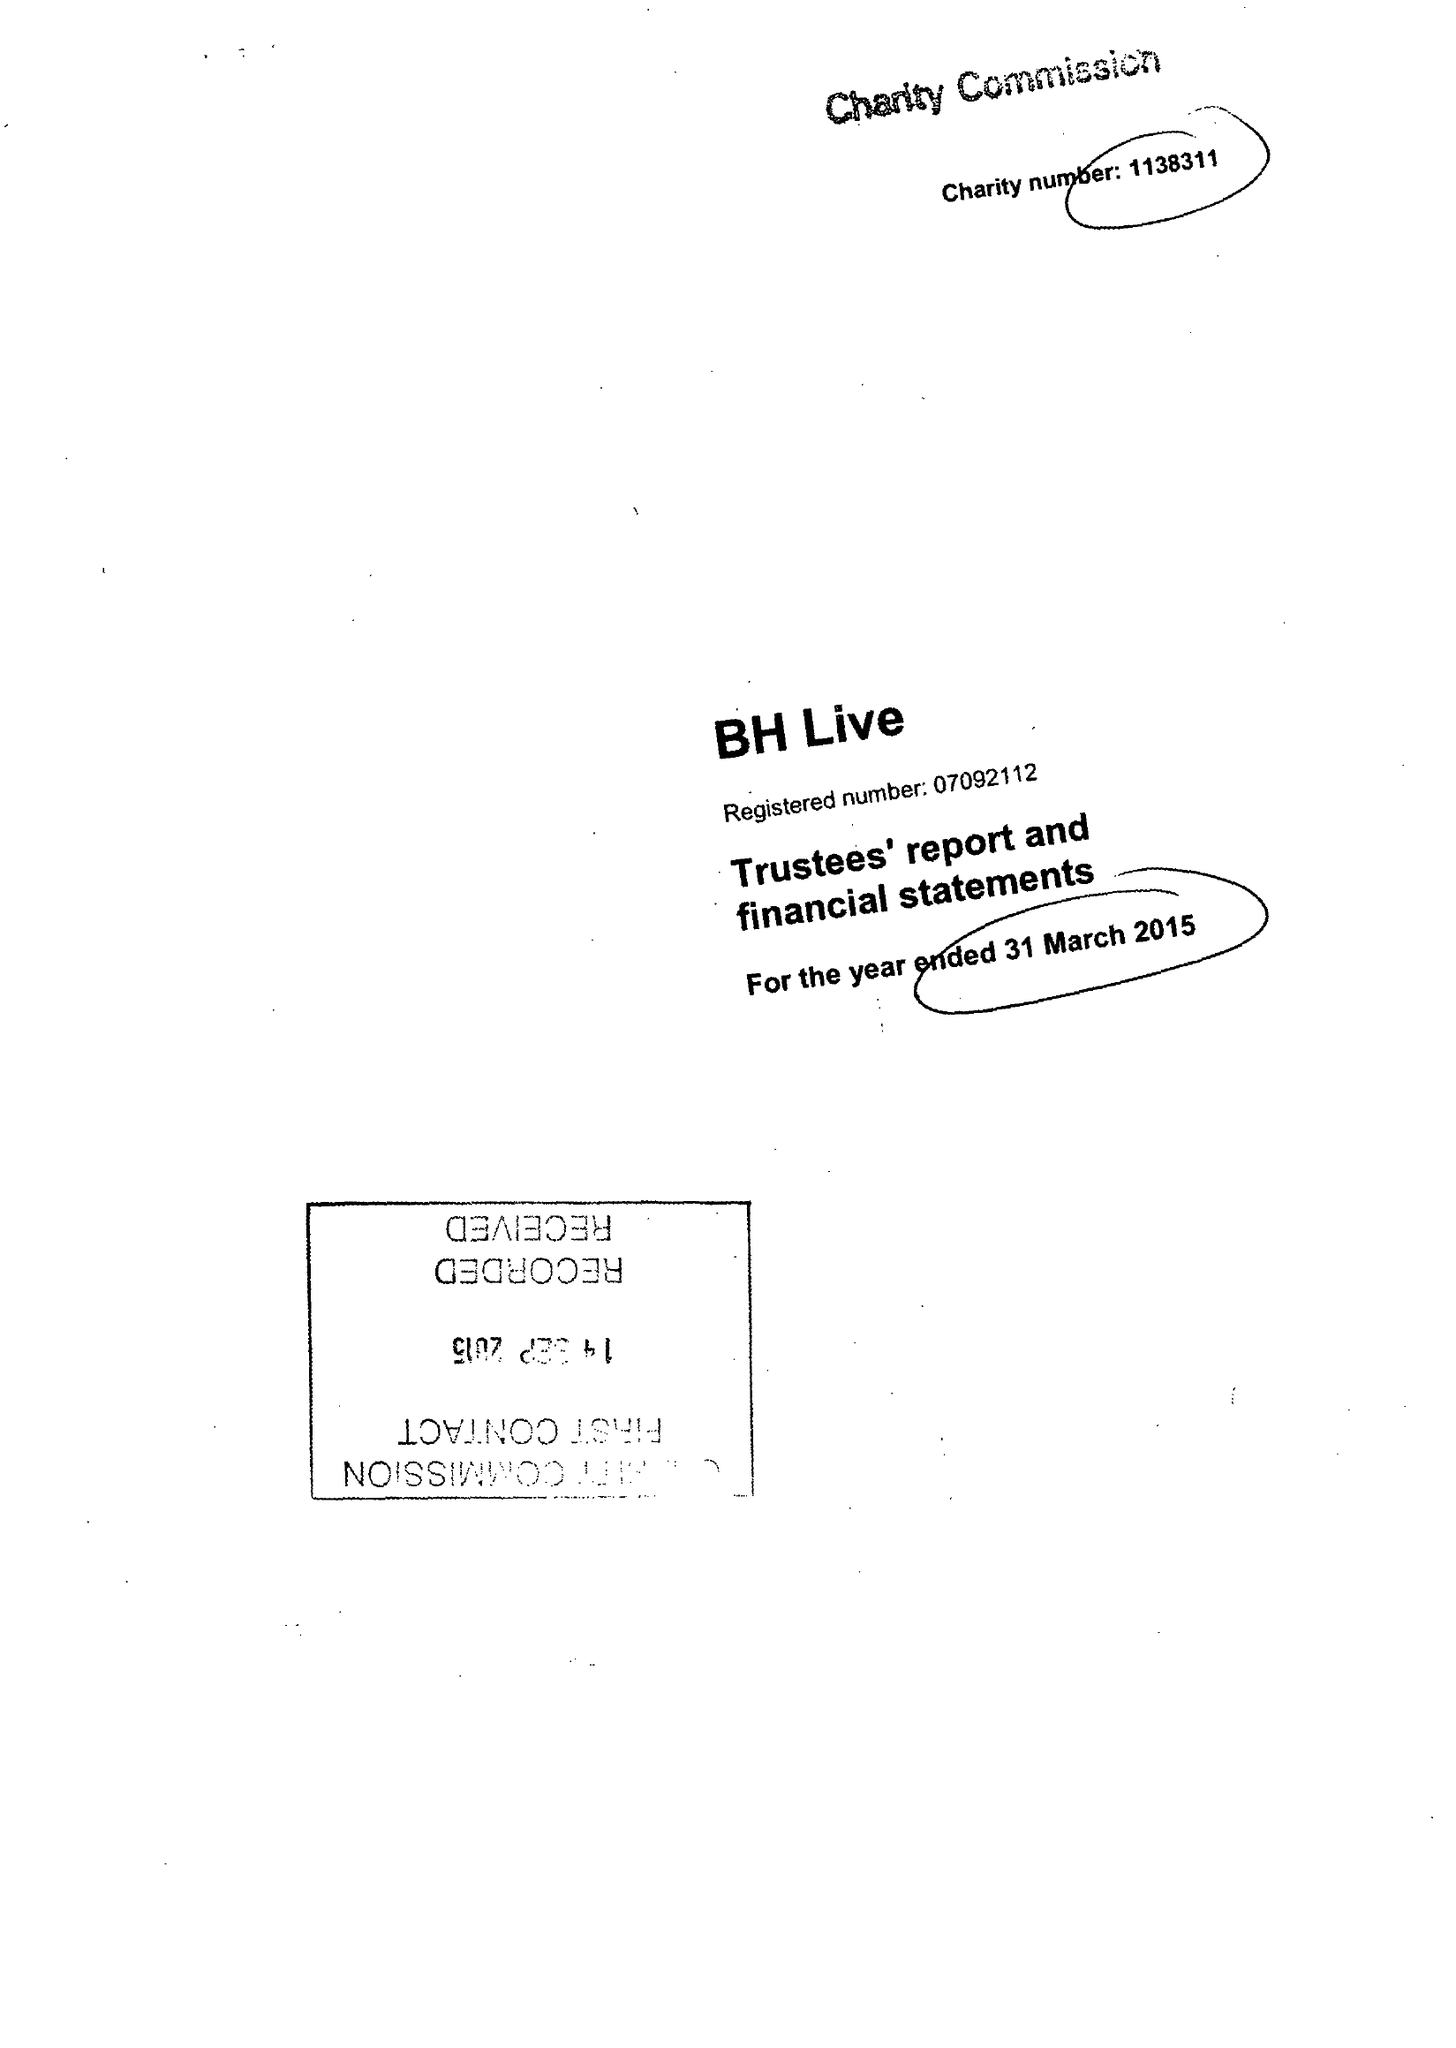What is the value for the address__post_town?
Answer the question using a single word or phrase. BOURNEMOUTH 